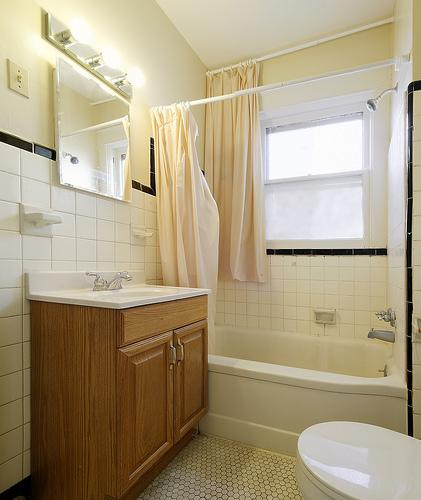Question: when do you close the curtain?
Choices:
A. To shower.
B. When it's night time.
C. When it's being cleaned.
D. When you want to see the design.
Answer with the letter. Answer: A Question: where is the toilet tissue?
Choices:
A. Next to the toilet.
B. Under the sink.
C. On the counter.
D. On the shelf.
Answer with the letter. Answer: A 